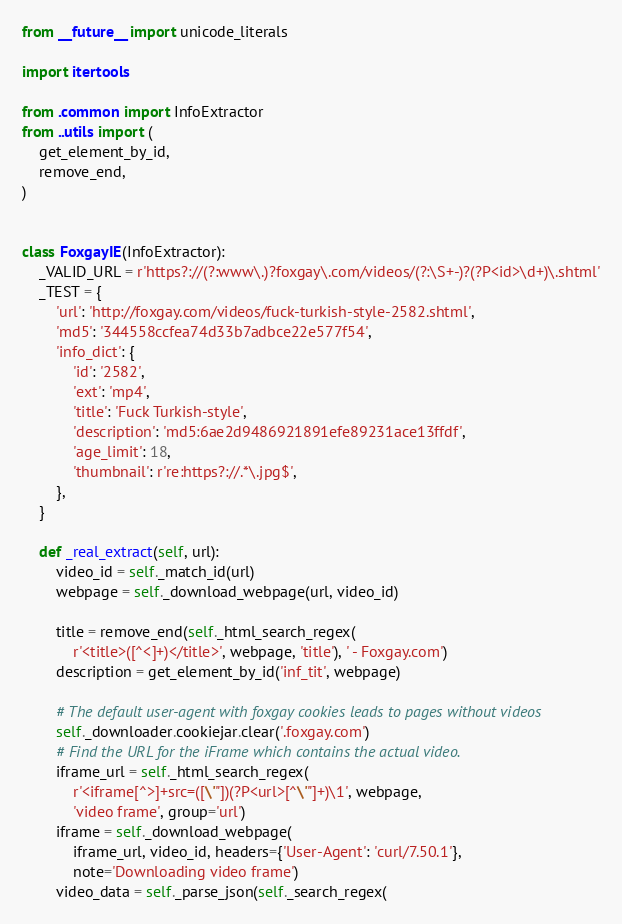Convert code to text. <code><loc_0><loc_0><loc_500><loc_500><_Python_>from __future__ import unicode_literals

import itertools

from .common import InfoExtractor
from ..utils import (
    get_element_by_id,
    remove_end,
)


class FoxgayIE(InfoExtractor):
    _VALID_URL = r'https?://(?:www\.)?foxgay\.com/videos/(?:\S+-)?(?P<id>\d+)\.shtml'
    _TEST = {
        'url': 'http://foxgay.com/videos/fuck-turkish-style-2582.shtml',
        'md5': '344558ccfea74d33b7adbce22e577f54',
        'info_dict': {
            'id': '2582',
            'ext': 'mp4',
            'title': 'Fuck Turkish-style',
            'description': 'md5:6ae2d9486921891efe89231ace13ffdf',
            'age_limit': 18,
            'thumbnail': r're:https?://.*\.jpg$',
        },
    }

    def _real_extract(self, url):
        video_id = self._match_id(url)
        webpage = self._download_webpage(url, video_id)

        title = remove_end(self._html_search_regex(
            r'<title>([^<]+)</title>', webpage, 'title'), ' - Foxgay.com')
        description = get_element_by_id('inf_tit', webpage)

        # The default user-agent with foxgay cookies leads to pages without videos
        self._downloader.cookiejar.clear('.foxgay.com')
        # Find the URL for the iFrame which contains the actual video.
        iframe_url = self._html_search_regex(
            r'<iframe[^>]+src=([\'"])(?P<url>[^\'"]+)\1', webpage,
            'video frame', group='url')
        iframe = self._download_webpage(
            iframe_url, video_id, headers={'User-Agent': 'curl/7.50.1'},
            note='Downloading video frame')
        video_data = self._parse_json(self._search_regex(</code> 